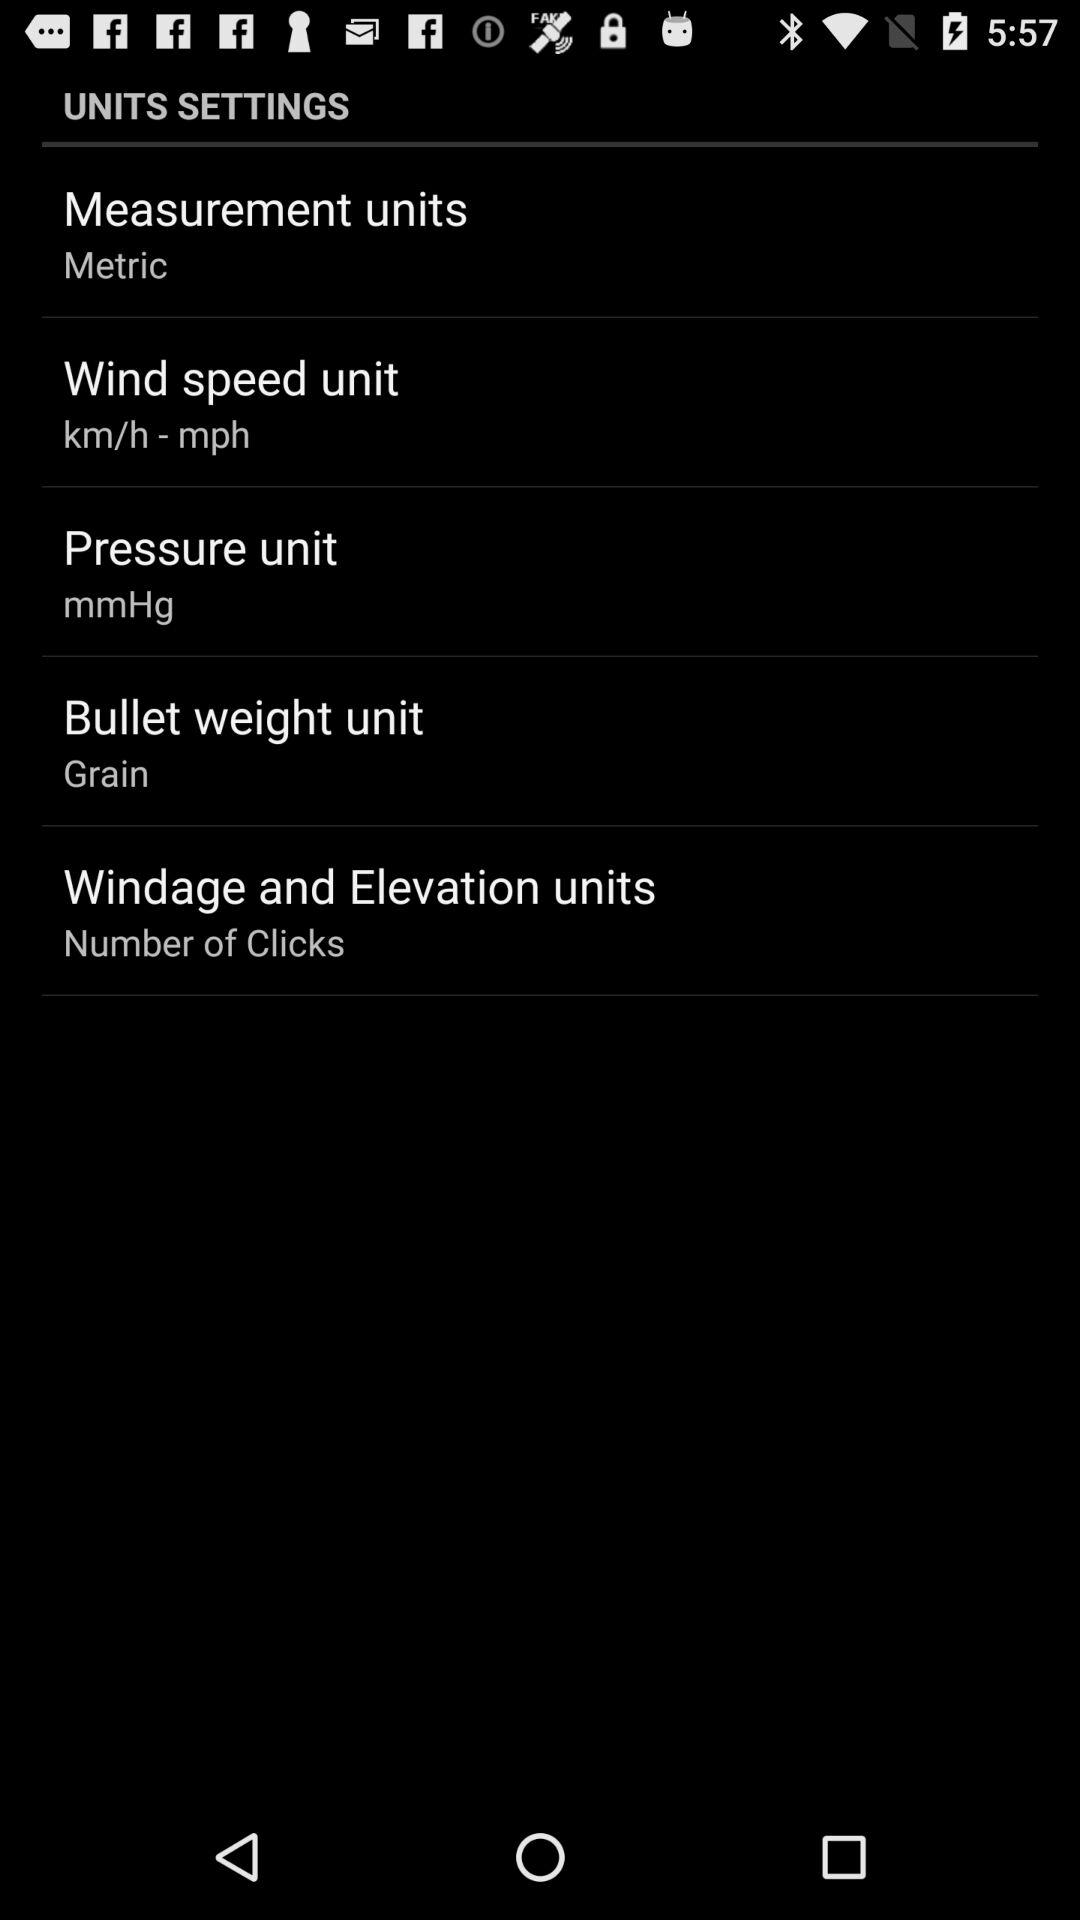What is the pressure unit? The pressure unit is "mmHg". 